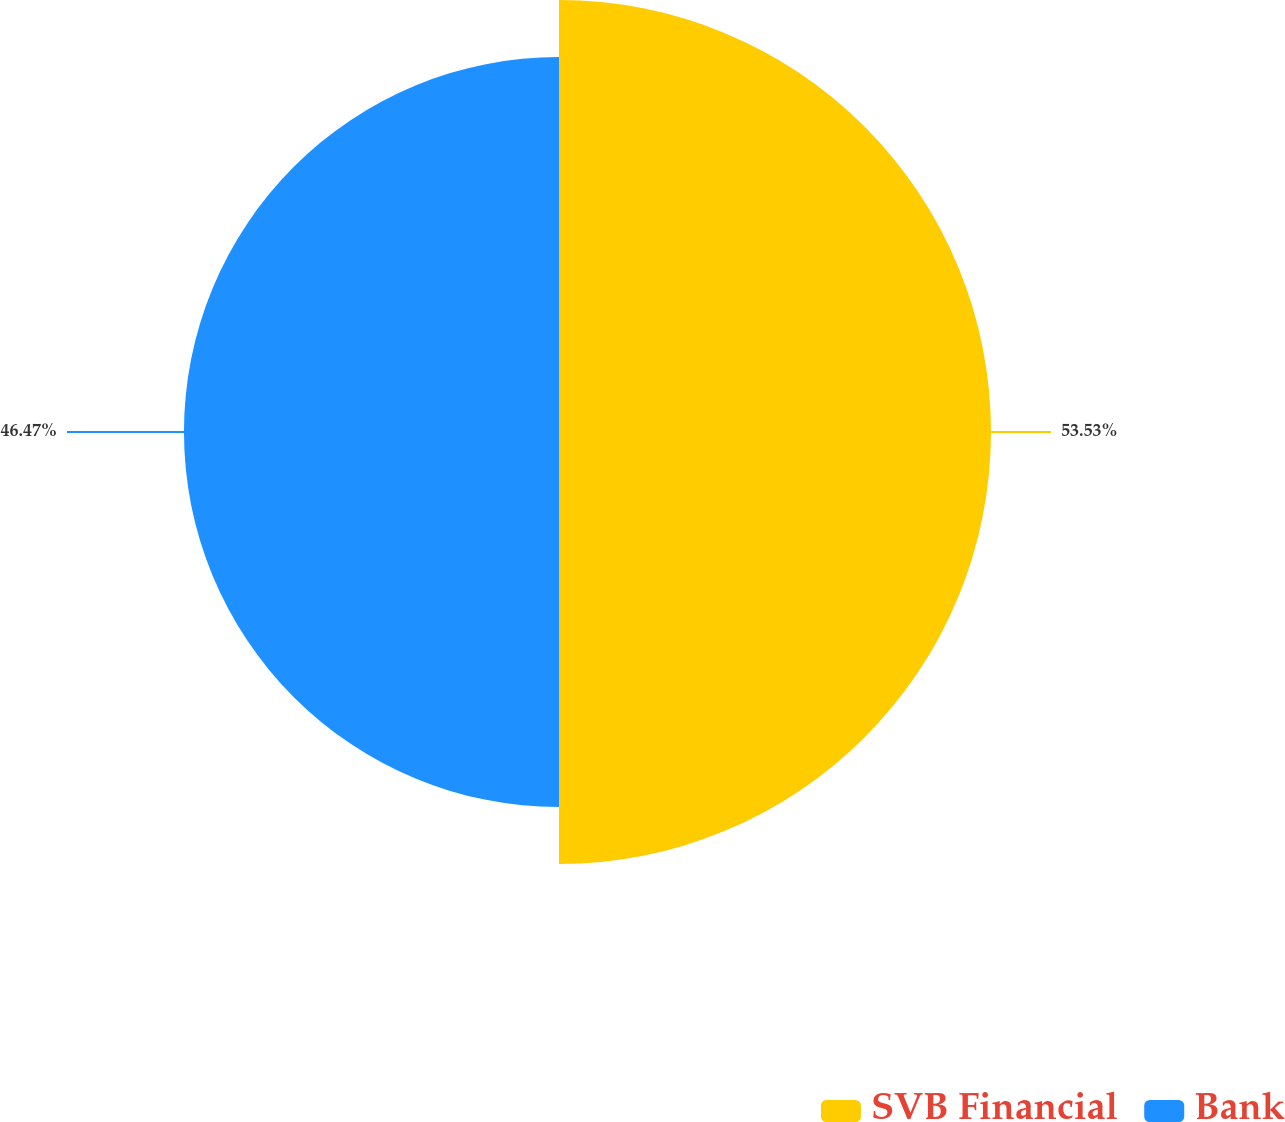Convert chart to OTSL. <chart><loc_0><loc_0><loc_500><loc_500><pie_chart><fcel>SVB Financial<fcel>Bank<nl><fcel>53.53%<fcel>46.47%<nl></chart> 